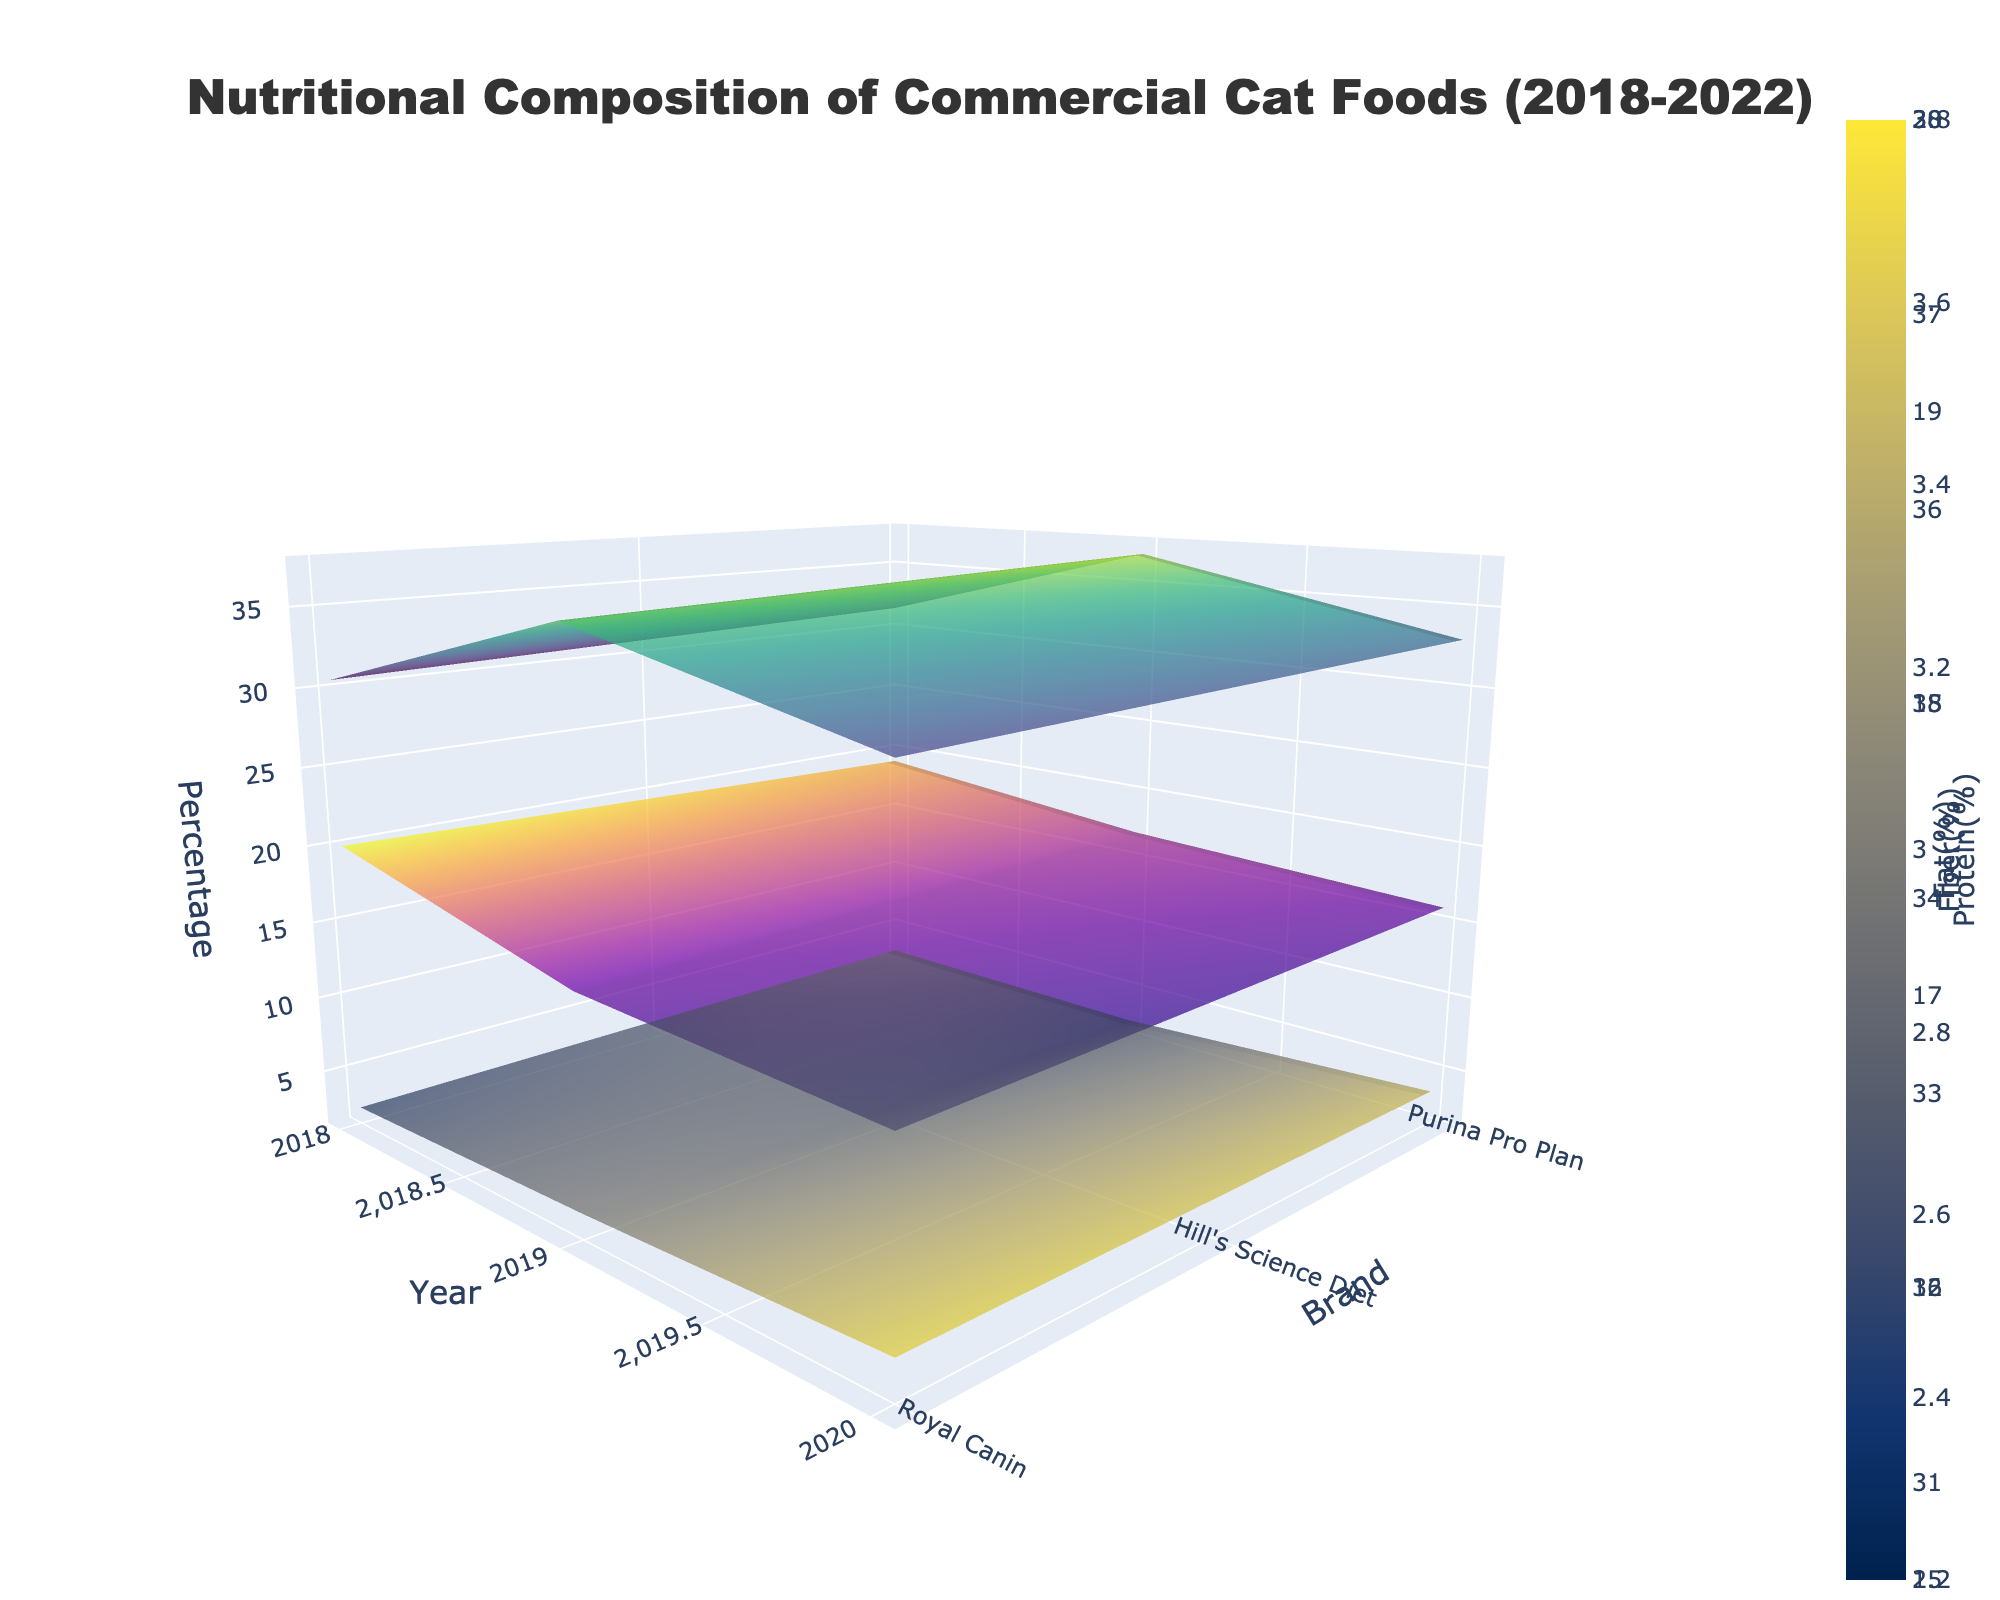What brands are compared in this plot? The plot uses the y-axis to represent different brands of commercial cat foods. We can see from the y-axis that the brands compared are Royal Canin, Hill's Science Diet, and Purina Pro Plan.
Answer: Royal Canin, Hill's Science Diet, Purina Pro Plan What period does this plot cover? The x-axis of the plot represents the years analyzed. By examining the axis, it is clear that the analysis covers the period from 2018 to 2022.
Answer: 2018-2022 Which nutritional component is displayed with a 'Viridis' color scale? Each surface in the plot represents a different nutritional component, and they use distinct color scales. According to the legend, the 'Viridis' color scale is used to display the Protein(%) surface.
Answer: Protein(%) In which year did Purina Pro Plan have the highest fiber percentage? Looking at the fiber(%) surface and focusing on the Purina Pro Plan brand along the y-axis, we can compare the fiber levels across the years. The highest peak for fiber is observed in the year 2018.
Answer: 2018 Did Hill's Science Diet's fat content increase or decrease from 2018 to 2022? By examining the fat(%) surface and looking at the trend for Hill's Science Diet along the years on the x-axis, we observe that the fat content decreases from 20.0% in 2018 to 18.0% in 2022.
Answer: Decrease Which brand showed the most significant increase in protein content from 2018 to 2022? Comparing the protein(%) surface for all brands, we see that Royal Canin shows a substantial increase from 32.0% in 2018 to 34.0% in 2022, which is the most significant increase among the brands.
Answer: Royal Canin In 2021, which brand and flavor combination had the highest fat percentage? By examining the fat(%) surface for the year 2021 and looking at the different brands, we see that Purina Pro Plan (Beef flavor) has the highest fat percentage, which is 17.5%.
Answer: Purina Pro Plan, Beef On average, how did the fiber content change for Royal Canin from 2018 to 2022? To find the average change, we look at the fiber(%) surface values for Royal Canin each year: 3.8, 3.7, 3.6, 3.5, and 3.4. The content follows a decreasing trend year by year.
Answer: Decreased Between 2019 and 2020, which brand showed a decrease in protein content? We need to compare the protein(%) surface values between 2019 and 2020 for each brand. Only Hill's Science Diet showed a decrease in protein content, going from 31.0% in 2019 to 31.5% in 2020.
Answer: Hill's Science Diet Are there any brands that have an increasing trend for all three nutritional components? By examining all three surfaces (protein, fat, and fiber), we can infer that Purina Pro Plan shows an increasing trend across all three components from 2018 to 2022.
Answer: Purina Pro Plan 